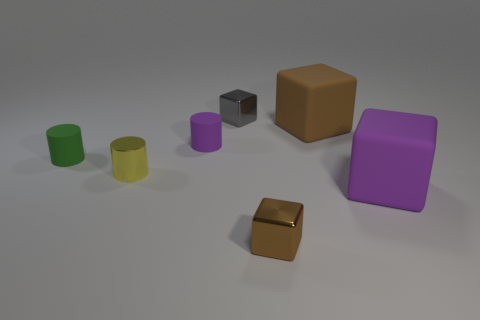Add 1 big things. How many objects exist? 8 Subtract all cylinders. How many objects are left? 4 Subtract all tiny green matte objects. Subtract all large brown rubber objects. How many objects are left? 5 Add 4 green matte things. How many green matte things are left? 5 Add 2 large purple things. How many large purple things exist? 3 Subtract 1 green cylinders. How many objects are left? 6 